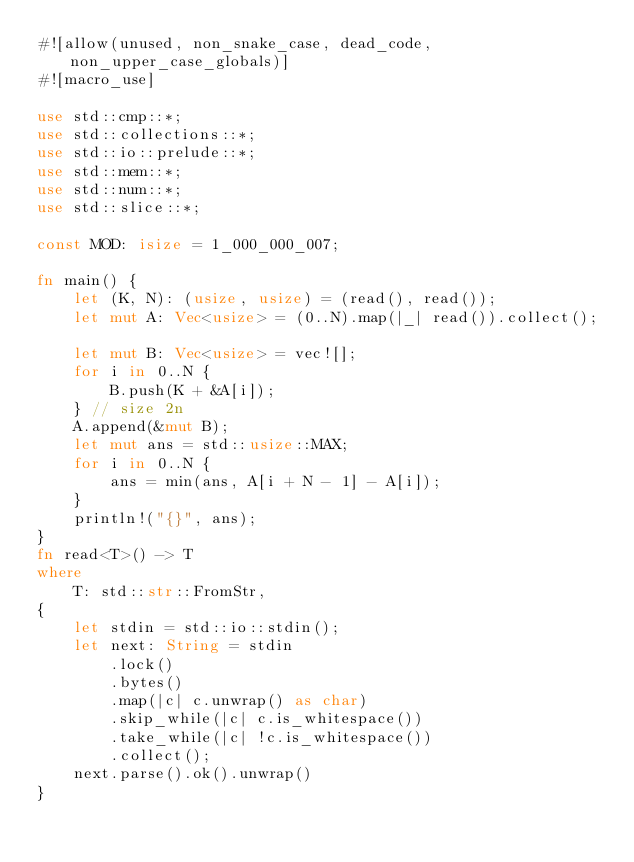<code> <loc_0><loc_0><loc_500><loc_500><_Rust_>#![allow(unused, non_snake_case, dead_code, non_upper_case_globals)]
#![macro_use]

use std::cmp::*;
use std::collections::*;
use std::io::prelude::*;
use std::mem::*;
use std::num::*;
use std::slice::*;

const MOD: isize = 1_000_000_007;

fn main() {
    let (K, N): (usize, usize) = (read(), read());
    let mut A: Vec<usize> = (0..N).map(|_| read()).collect();

    let mut B: Vec<usize> = vec![];
    for i in 0..N {
        B.push(K + &A[i]);
    } // size 2n
    A.append(&mut B);
    let mut ans = std::usize::MAX;
    for i in 0..N {
        ans = min(ans, A[i + N - 1] - A[i]);
    }
    println!("{}", ans);
}
fn read<T>() -> T
where
    T: std::str::FromStr,
{
    let stdin = std::io::stdin();
    let next: String = stdin
        .lock()
        .bytes()
        .map(|c| c.unwrap() as char)
        .skip_while(|c| c.is_whitespace())
        .take_while(|c| !c.is_whitespace())
        .collect();
    next.parse().ok().unwrap()
}
</code> 